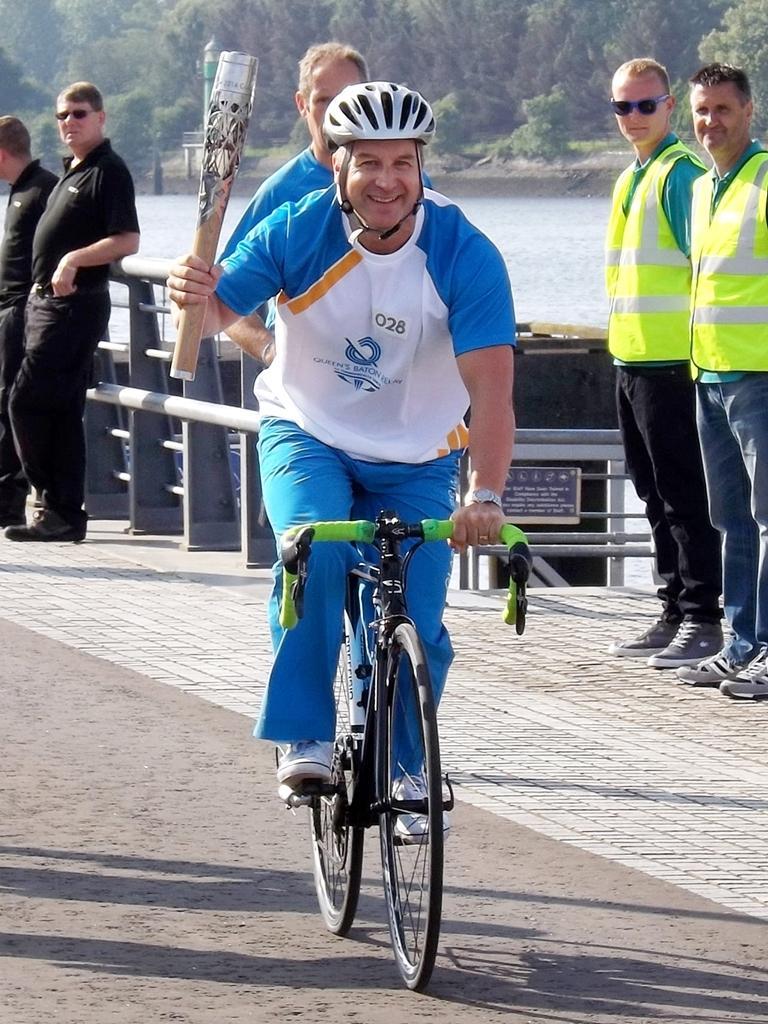In one or two sentences, can you explain what this image depicts? In this image there is a person wearing blue color dress riding bicycle and holding something in his right hand and at the background of the image there are persons standing leaning on the fencing and there are trees and water. 